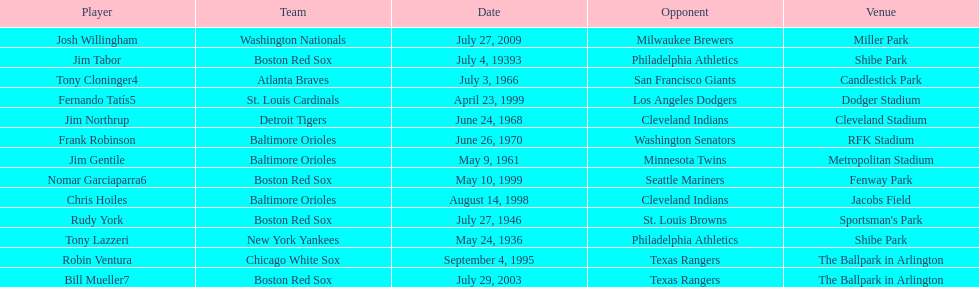On what date did the detroit tigers play the cleveland indians? June 24, 1968. 